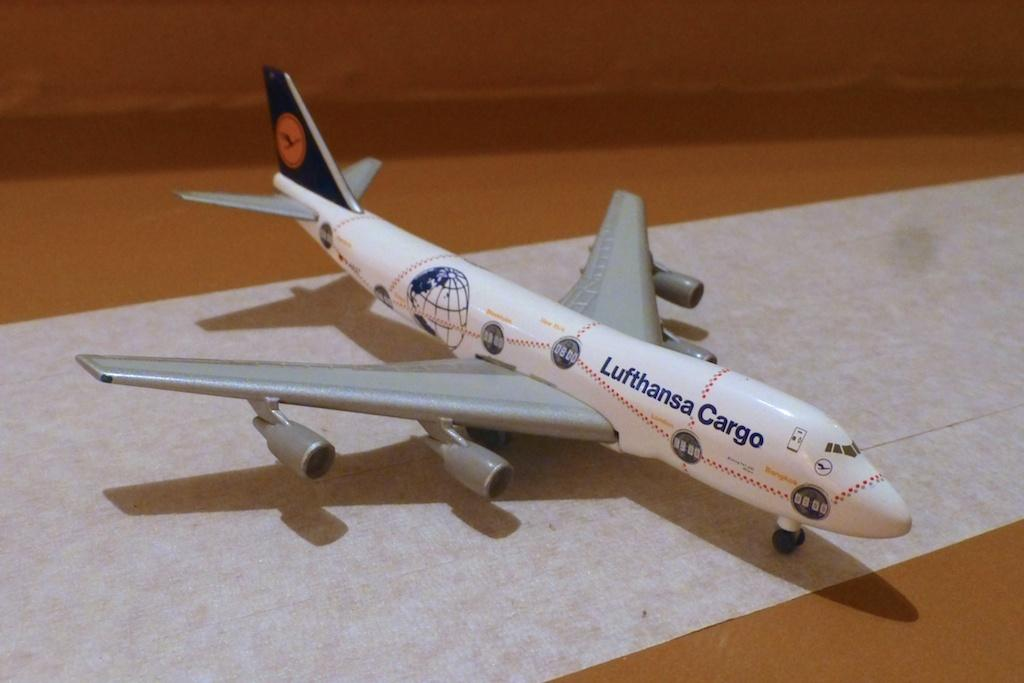<image>
Give a short and clear explanation of the subsequent image. A model Lufthansa Cargo airplane sitting on a long sheet of white paper 